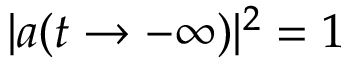<formula> <loc_0><loc_0><loc_500><loc_500>| a ( t \rightarrow - \infty ) | ^ { 2 } = 1</formula> 